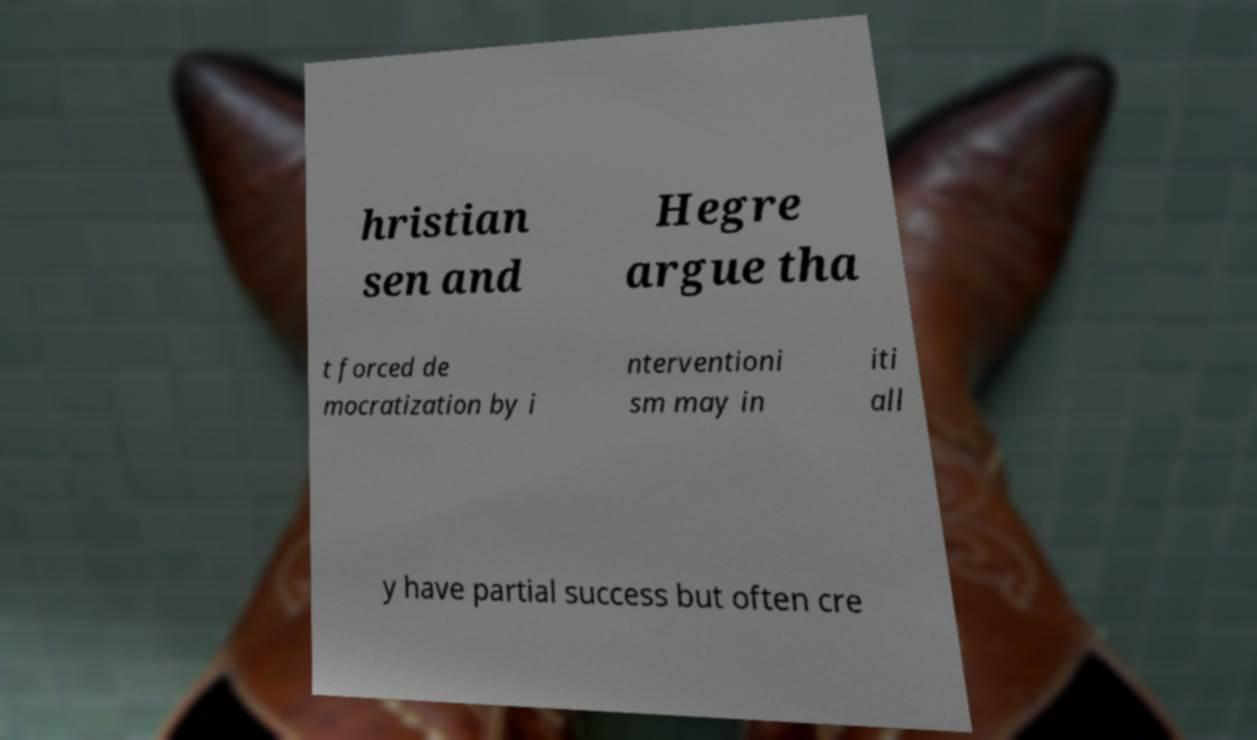There's text embedded in this image that I need extracted. Can you transcribe it verbatim? hristian sen and Hegre argue tha t forced de mocratization by i nterventioni sm may in iti all y have partial success but often cre 